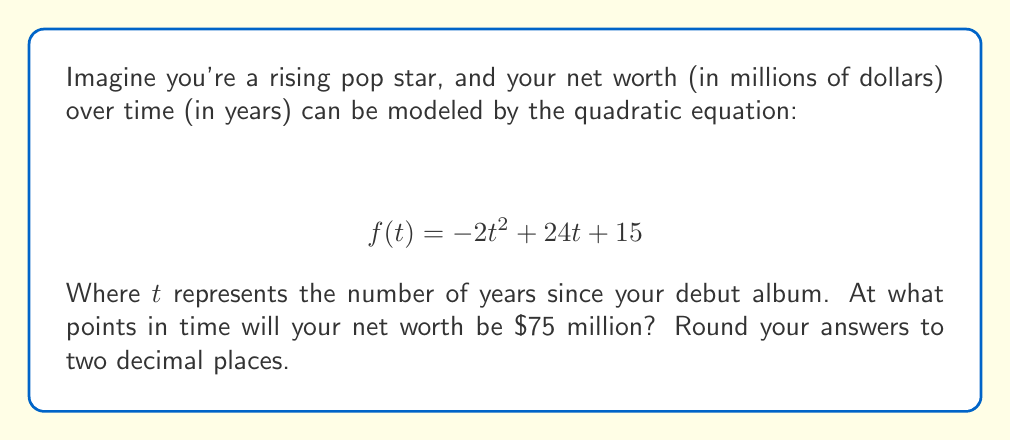Help me with this question. To solve this problem, we need to find the roots of the equation $f(t) = 75$. Let's approach this step-by-step:

1) First, we set up the equation:
   $$ -2t^2 + 24t + 15 = 75 $$

2) Subtract 75 from both sides to get the equation in standard form:
   $$ -2t^2 + 24t - 60 = 0 $$

3) Divide everything by -2 to make the leading coefficient 1:
   $$ t^2 - 12t + 30 = 0 $$

4) Now we can use the quadratic formula: $t = \frac{-b \pm \sqrt{b^2 - 4ac}}{2a}$
   Where $a = 1$, $b = -12$, and $c = 30$

5) Plugging these values into the quadratic formula:
   $$ t = \frac{12 \pm \sqrt{(-12)^2 - 4(1)(30)}}{2(1)} $$

6) Simplify under the square root:
   $$ t = \frac{12 \pm \sqrt{144 - 120}}{2} = \frac{12 \pm \sqrt{24}}{2} $$

7) Simplify $\sqrt{24}$:
   $$ t = \frac{12 \pm 2\sqrt{6}}{2} $$

8) Simplify the fraction:
   $$ t = 6 \pm \sqrt{6} $$

9) Calculate the two solutions:
   $t_1 = 6 + \sqrt{6} \approx 8.45$
   $t_2 = 6 - \sqrt{6} \approx 3.55$

Therefore, your net worth will be $75 million approximately 3.55 years and 8.45 years after your debut album.
Answer: The net worth will be $75 million at approximately 3.55 years and 8.45 years after the debut album. 